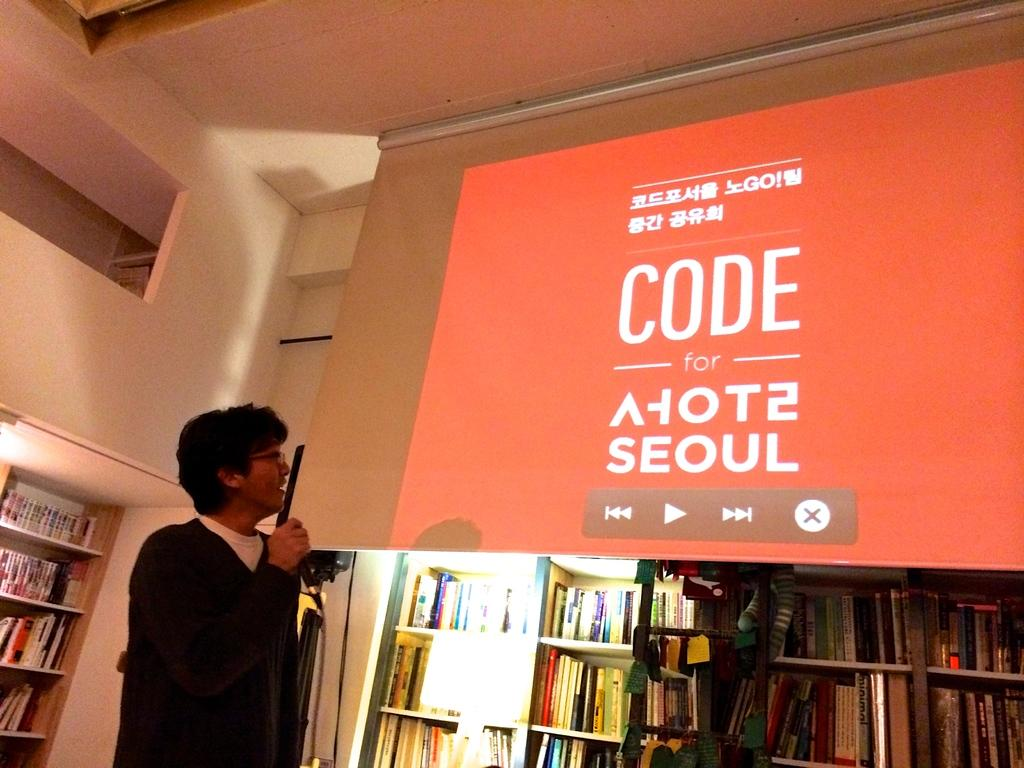Provide a one-sentence caption for the provided image. A man gives a speech about the projector screen which shows the Asian language and English writings as CODE for seoul. 